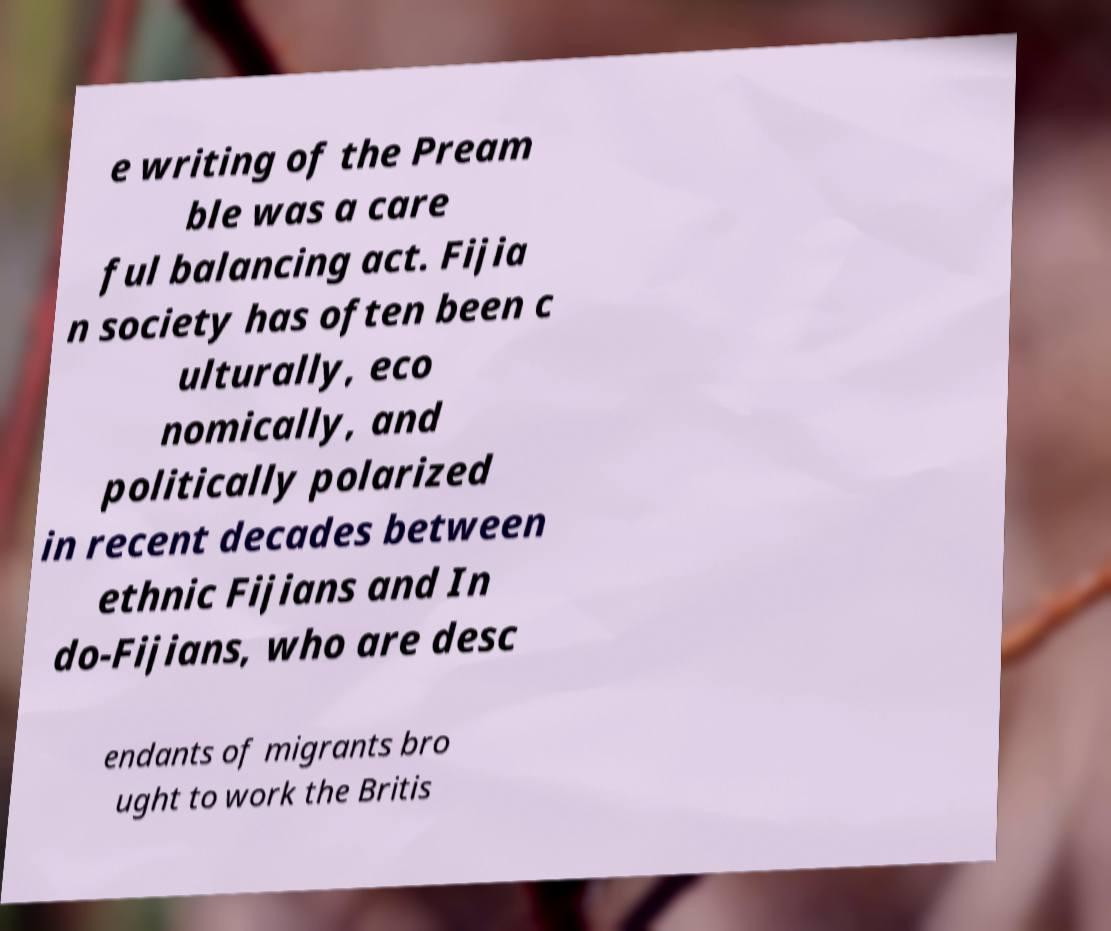There's text embedded in this image that I need extracted. Can you transcribe it verbatim? e writing of the Pream ble was a care ful balancing act. Fijia n society has often been c ulturally, eco nomically, and politically polarized in recent decades between ethnic Fijians and In do-Fijians, who are desc endants of migrants bro ught to work the Britis 